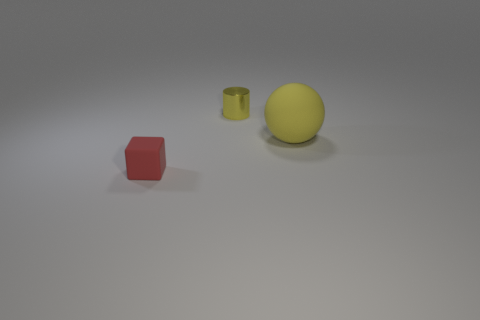Add 3 yellow balls. How many objects exist? 6 Subtract all cylinders. How many objects are left? 2 Add 1 small metal objects. How many small metal objects exist? 2 Subtract 0 yellow blocks. How many objects are left? 3 Subtract all blue cubes. Subtract all yellow spheres. How many objects are left? 2 Add 2 yellow rubber things. How many yellow rubber things are left? 3 